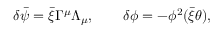Convert formula to latex. <formula><loc_0><loc_0><loc_500><loc_500>\delta \bar { \psi } = \bar { \xi } \Gamma ^ { \mu } \Lambda _ { \mu } , \quad \delta \phi = - \phi ^ { 2 } ( \bar { \xi } \theta ) ,</formula> 